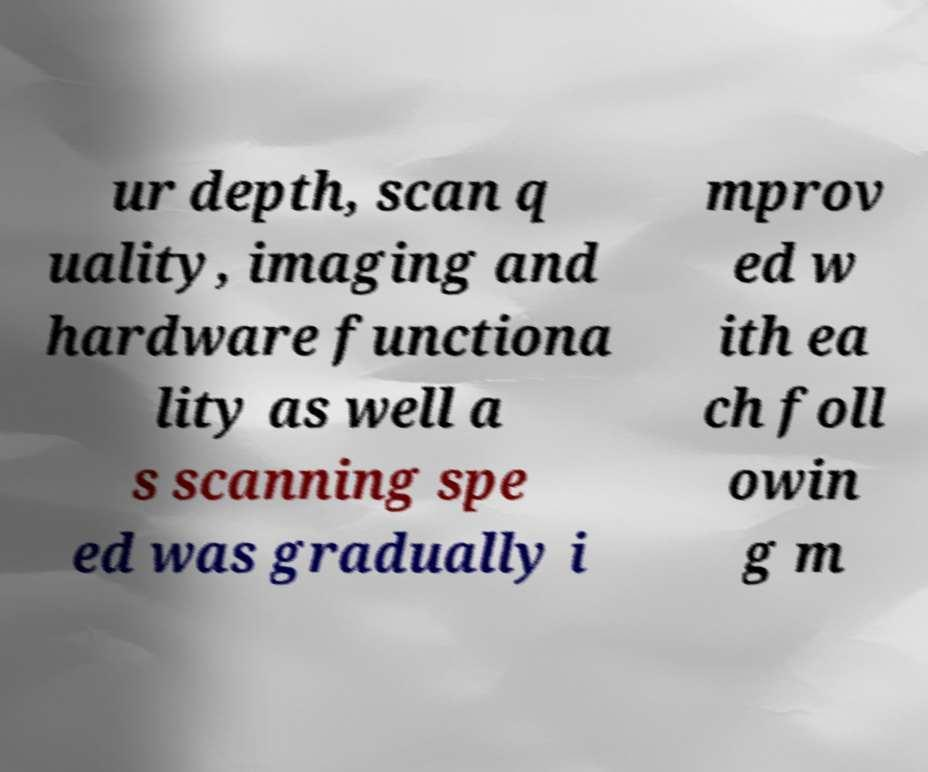For documentation purposes, I need the text within this image transcribed. Could you provide that? ur depth, scan q uality, imaging and hardware functiona lity as well a s scanning spe ed was gradually i mprov ed w ith ea ch foll owin g m 